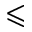<formula> <loc_0><loc_0><loc_500><loc_500>\leqslant</formula> 